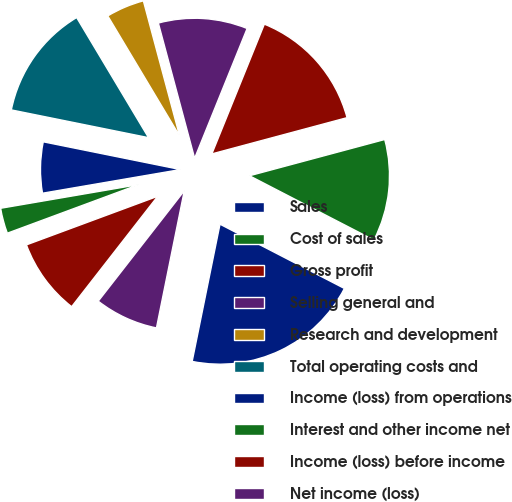Convert chart to OTSL. <chart><loc_0><loc_0><loc_500><loc_500><pie_chart><fcel>Sales<fcel>Cost of sales<fcel>Gross profit<fcel>Selling general and<fcel>Research and development<fcel>Total operating costs and<fcel>Income (loss) from operations<fcel>Interest and other income net<fcel>Income (loss) before income<fcel>Net income (loss)<nl><fcel>20.59%<fcel>11.76%<fcel>14.71%<fcel>10.29%<fcel>4.41%<fcel>13.24%<fcel>5.88%<fcel>2.94%<fcel>8.82%<fcel>7.35%<nl></chart> 